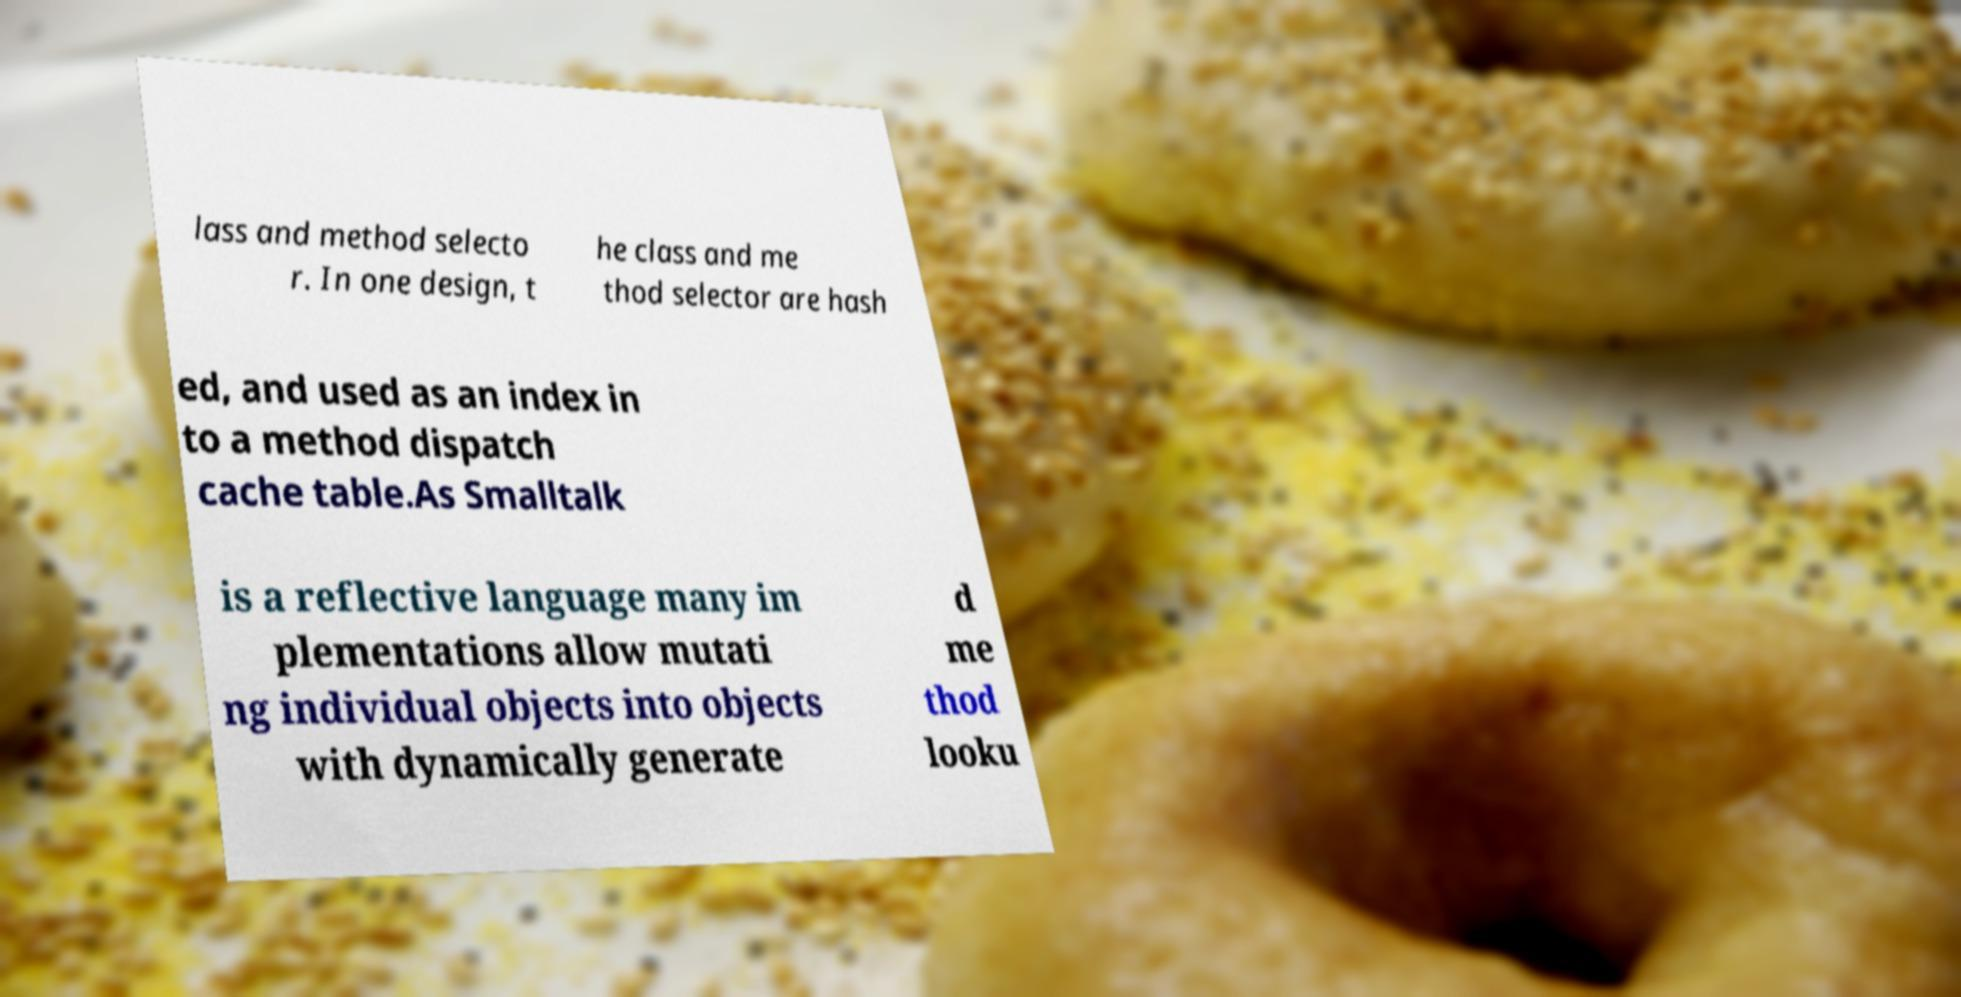Can you accurately transcribe the text from the provided image for me? lass and method selecto r. In one design, t he class and me thod selector are hash ed, and used as an index in to a method dispatch cache table.As Smalltalk is a reflective language many im plementations allow mutati ng individual objects into objects with dynamically generate d me thod looku 